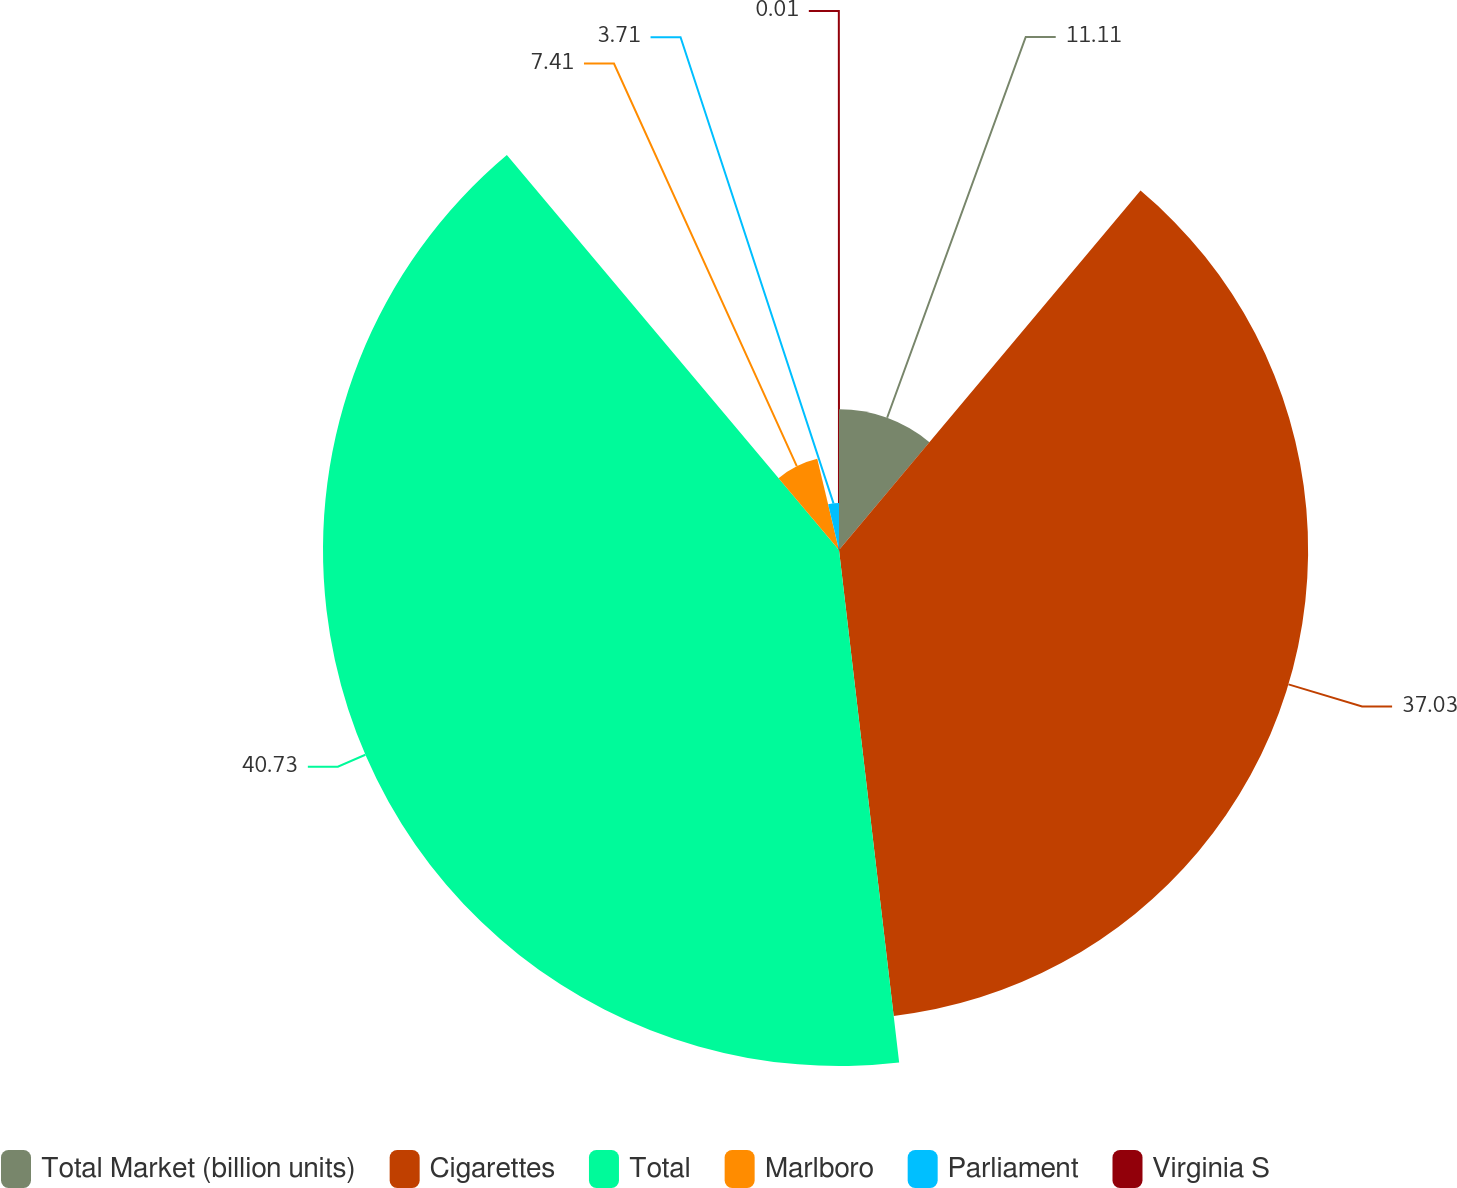<chart> <loc_0><loc_0><loc_500><loc_500><pie_chart><fcel>Total Market (billion units)<fcel>Cigarettes<fcel>Total<fcel>Marlboro<fcel>Parliament<fcel>Virginia S<nl><fcel>11.11%<fcel>37.03%<fcel>40.73%<fcel>7.41%<fcel>3.71%<fcel>0.01%<nl></chart> 